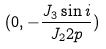<formula> <loc_0><loc_0><loc_500><loc_500>( 0 , - \frac { J _ { 3 } \sin i } { J _ { 2 } 2 p } )</formula> 